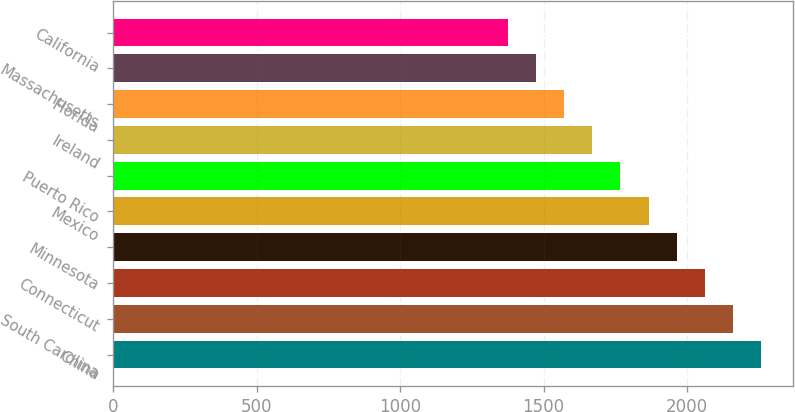<chart> <loc_0><loc_0><loc_500><loc_500><bar_chart><fcel>China<fcel>South Carolina<fcel>Connecticut<fcel>Minnesota<fcel>Mexico<fcel>Puerto Rico<fcel>Ireland<fcel>Florida<fcel>Massachusetts<fcel>California<nl><fcel>2255.6<fcel>2158<fcel>2060.4<fcel>1962.8<fcel>1865.2<fcel>1767.6<fcel>1670<fcel>1572.4<fcel>1474.8<fcel>1377.2<nl></chart> 